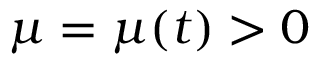Convert formula to latex. <formula><loc_0><loc_0><loc_500><loc_500>\mu = \mu ( t ) > 0</formula> 